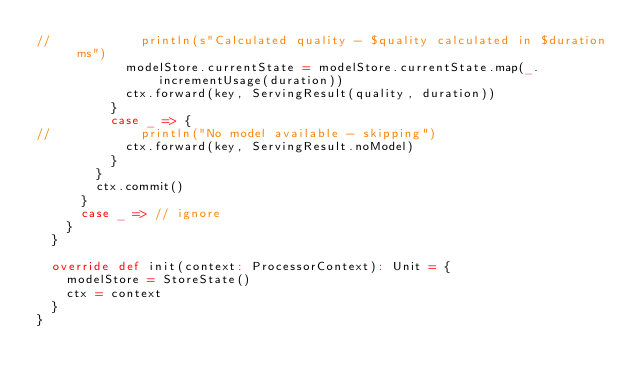Convert code to text. <code><loc_0><loc_0><loc_500><loc_500><_Scala_>//            println(s"Calculated quality - $quality calculated in $duration ms")
            modelStore.currentState = modelStore.currentState.map(_.incrementUsage(duration))
            ctx.forward(key, ServingResult(quality, duration))
          }
          case _ => {
//            println("No model available - skipping")
            ctx.forward(key, ServingResult.noModel)
          }
        }
        ctx.commit()
      }
      case _ => // ignore
    }
  }

  override def init(context: ProcessorContext): Unit = {
    modelStore = StoreState()
    ctx = context
  }
}
</code> 